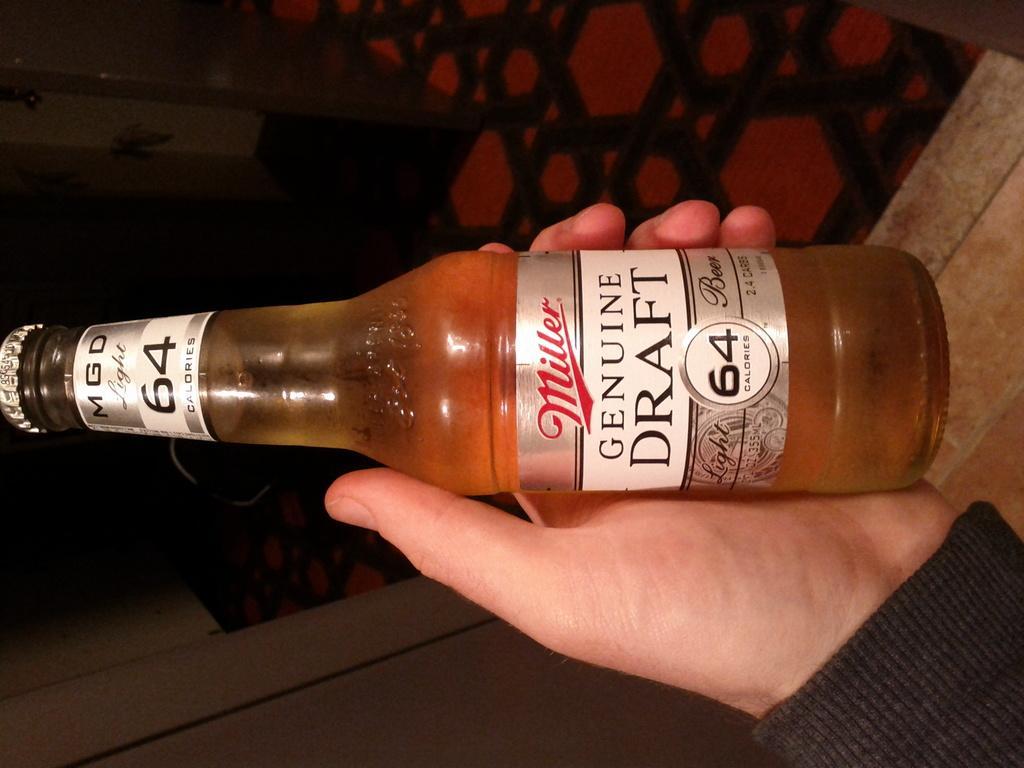In one or two sentences, can you explain what this image depicts? A wine bottle is held in a hand. The name of the bottle is genuine draft. 